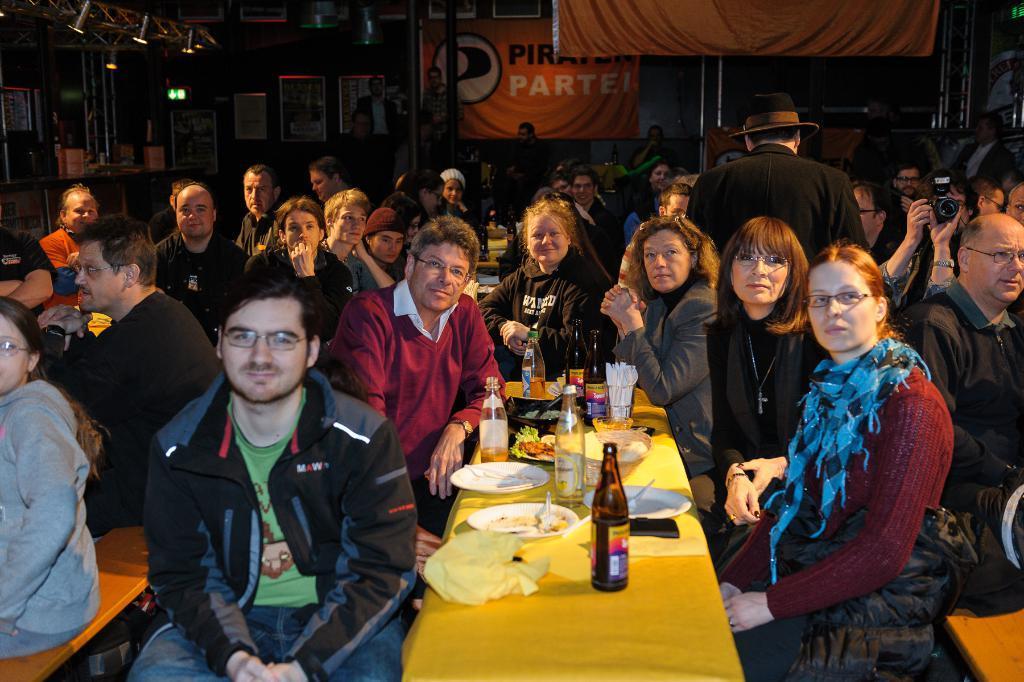Describe this image in one or two sentences. In this picture we can see so many people are sitting, in front we can see the table, on which e can see some plates, glasses, bottles are placed, behind we can see frames to the wall and we can see one banner. 